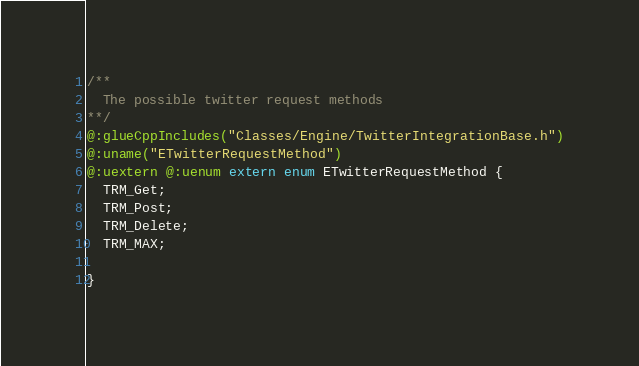<code> <loc_0><loc_0><loc_500><loc_500><_Haxe_>
/**
  The possible twitter request methods
**/
@:glueCppIncludes("Classes/Engine/TwitterIntegrationBase.h")
@:uname("ETwitterRequestMethod")
@:uextern @:uenum extern enum ETwitterRequestMethod {
  TRM_Get;
  TRM_Post;
  TRM_Delete;
  TRM_MAX;
  
}
</code> 